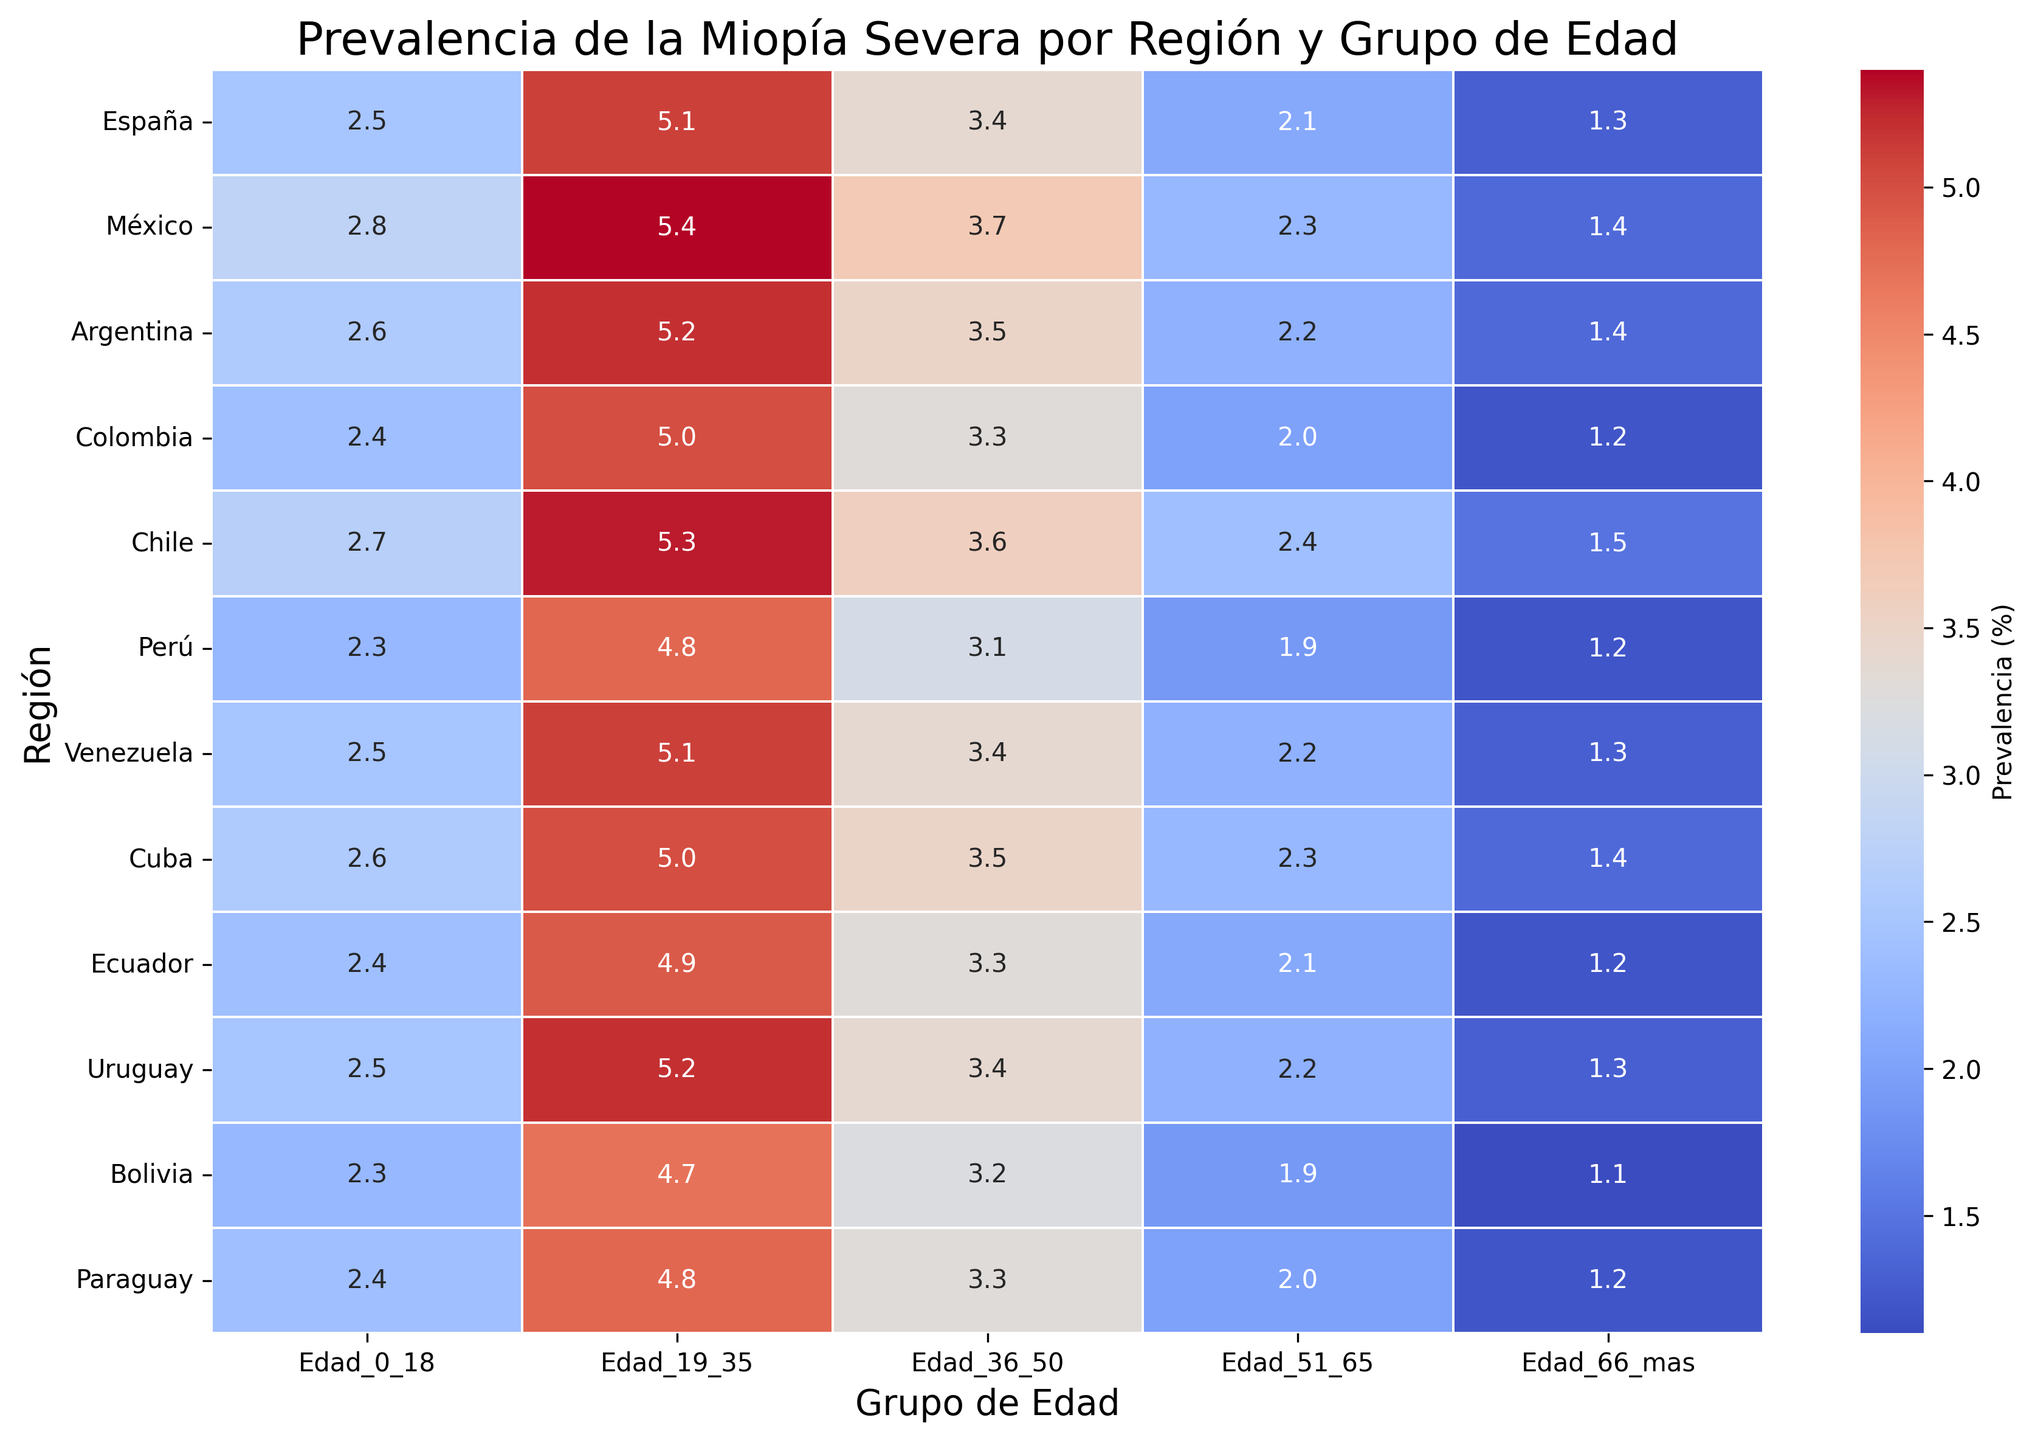¿Qué región tiene la prevalencia más alta de miopía severa en el grupo de edad 19-35 años? Observamos los valores en la columna "Edad_19_35" y comparamos entre todas las regiones, el valor más alto es 5.4 en México.
Answer: México ¿Cuál es la prevalencia promedio de miopía severa en España para todos los grupos de edad? Primero, sumamos los valores de todas las columnas para España: 2.5 + 5.1 + 3.4 + 2.1 + 1.3 = 14.4. Luego dividimos por el número de grupos de edad (5), para obtener 14.4 / 5 = 2.88.
Answer: 2.88 ¿En qué región es más alta la prevalencia de miopía severa en el grupo de edad 51-65 años? Comparando los valores en la columna "Edad_51_65", el valor más alto es 2.4 en Chile.
Answer: Chile ¿Hay alguna región donde la prevalencia de miopía severa sea igual en al menos dos grupos de edad? Revisamos cada fila y encontramos que en Colombia, la prevalencia en "Edad_0_18" y "Edad_66_mas" es 2.4 en ambos grupos.
Answer: Colombia ¿Cuál es la diferencia de prevalencia de miopía severa entre el grupo de edad 19-35 años y el 66+ en Argentina? Restamos el valor en "Edad_66_mas" del valor en "Edad_19_35" para Argentina: 5.2 − 1.4 = 3.8.
Answer: 3.8 ¿Qué grupo de edad tiene la menor prevalencia de miopía severa en Venezuela? Observando los valores de todas las columnas para Venezuela, el menor valor es 1.3 en el grupo "Edad_66_mas".
Answer: Edad_66_mas ¿Cuál es la prevalencia de miopía severa para el grupo de edad 0-18 en todas las regiones en total? Sumamos todos los valores de la columna "Edad_0_18": 2.5 + 2.8 + 2.6 + 2.4 + 2.7 + 2.3 + 2.5 + 2.6 + 2.4 + 2.5 + 2.3 + 2.4 = 31.
Answer: 31 ¿Cuál es la brecha de prevalencia entre las regiones con más alta y más baja prevalencia en el grupo de edad 36-50 años? El valor más alto en "Edad_36_50" es 3.7 en México y el más bajo es 3.1 en Perú. La diferencia es 3.7 − 3.1 = 0.6.
Answer: 0.6 ¿Cuáles dos regiones tienen la misma prevalencia de miopía severa en el grupo de edad 51-65 años? Observando los valores en la columna "Edad_51_65", España y Paraguay tienen ambos 2.1.
Answer: España y Paraguay 